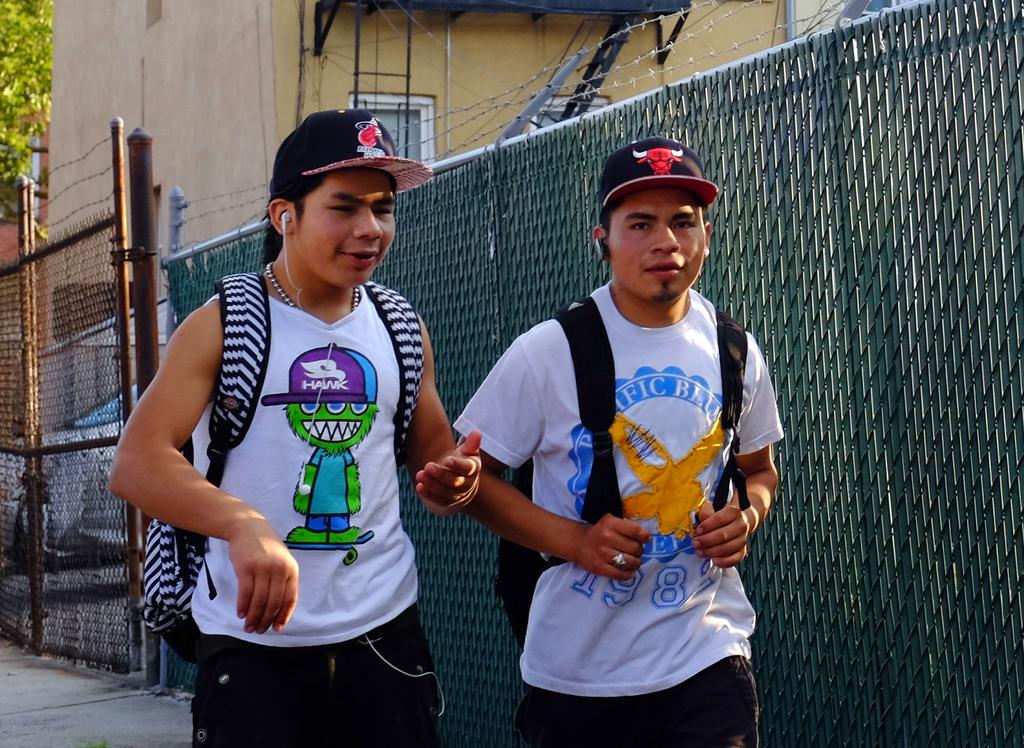<image>
Create a compact narrative representing the image presented. A kid is wearing a tank top with a character in a hat with a Hawk logo on it. 